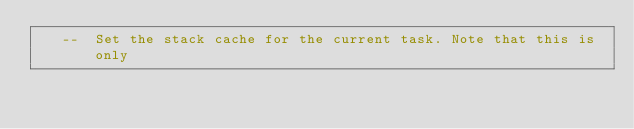Convert code to text. <code><loc_0><loc_0><loc_500><loc_500><_Ada_>   --  Set the stack cache for the current task. Note that this is only</code> 